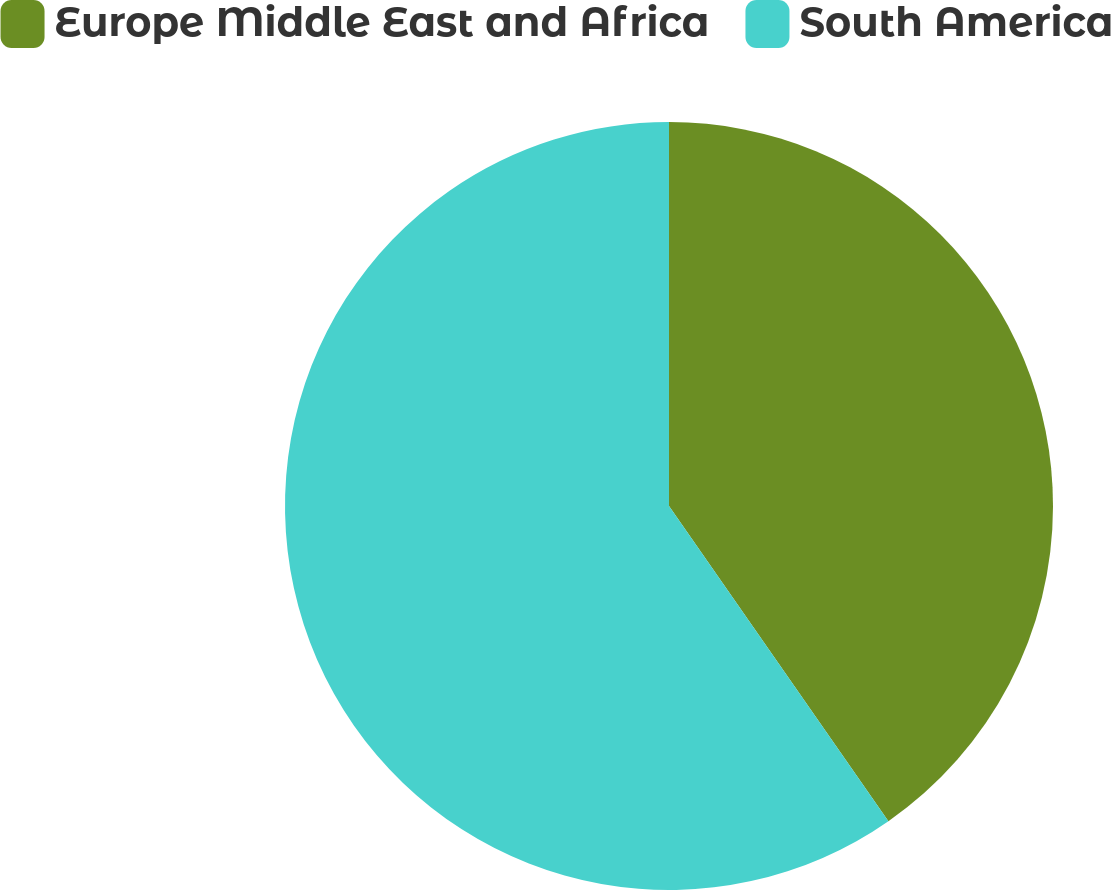Convert chart to OTSL. <chart><loc_0><loc_0><loc_500><loc_500><pie_chart><fcel>Europe Middle East and Africa<fcel>South America<nl><fcel>40.32%<fcel>59.68%<nl></chart> 